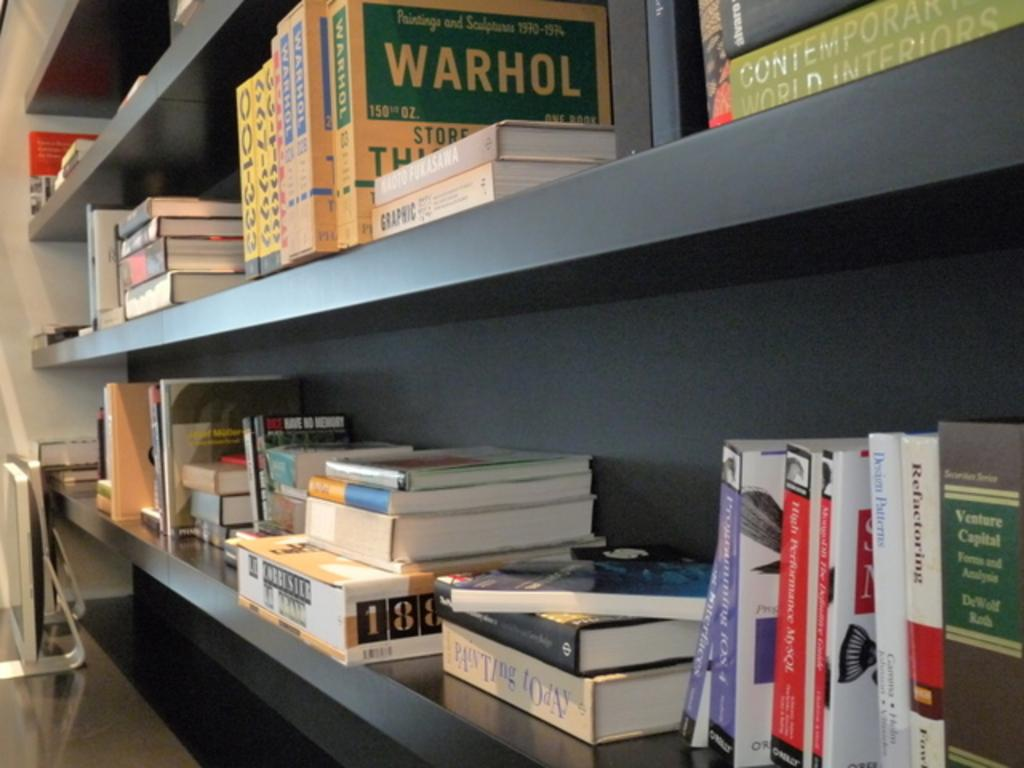<image>
Describe the image concisely. two shelves with one that has a box that says 'warhol' on it 